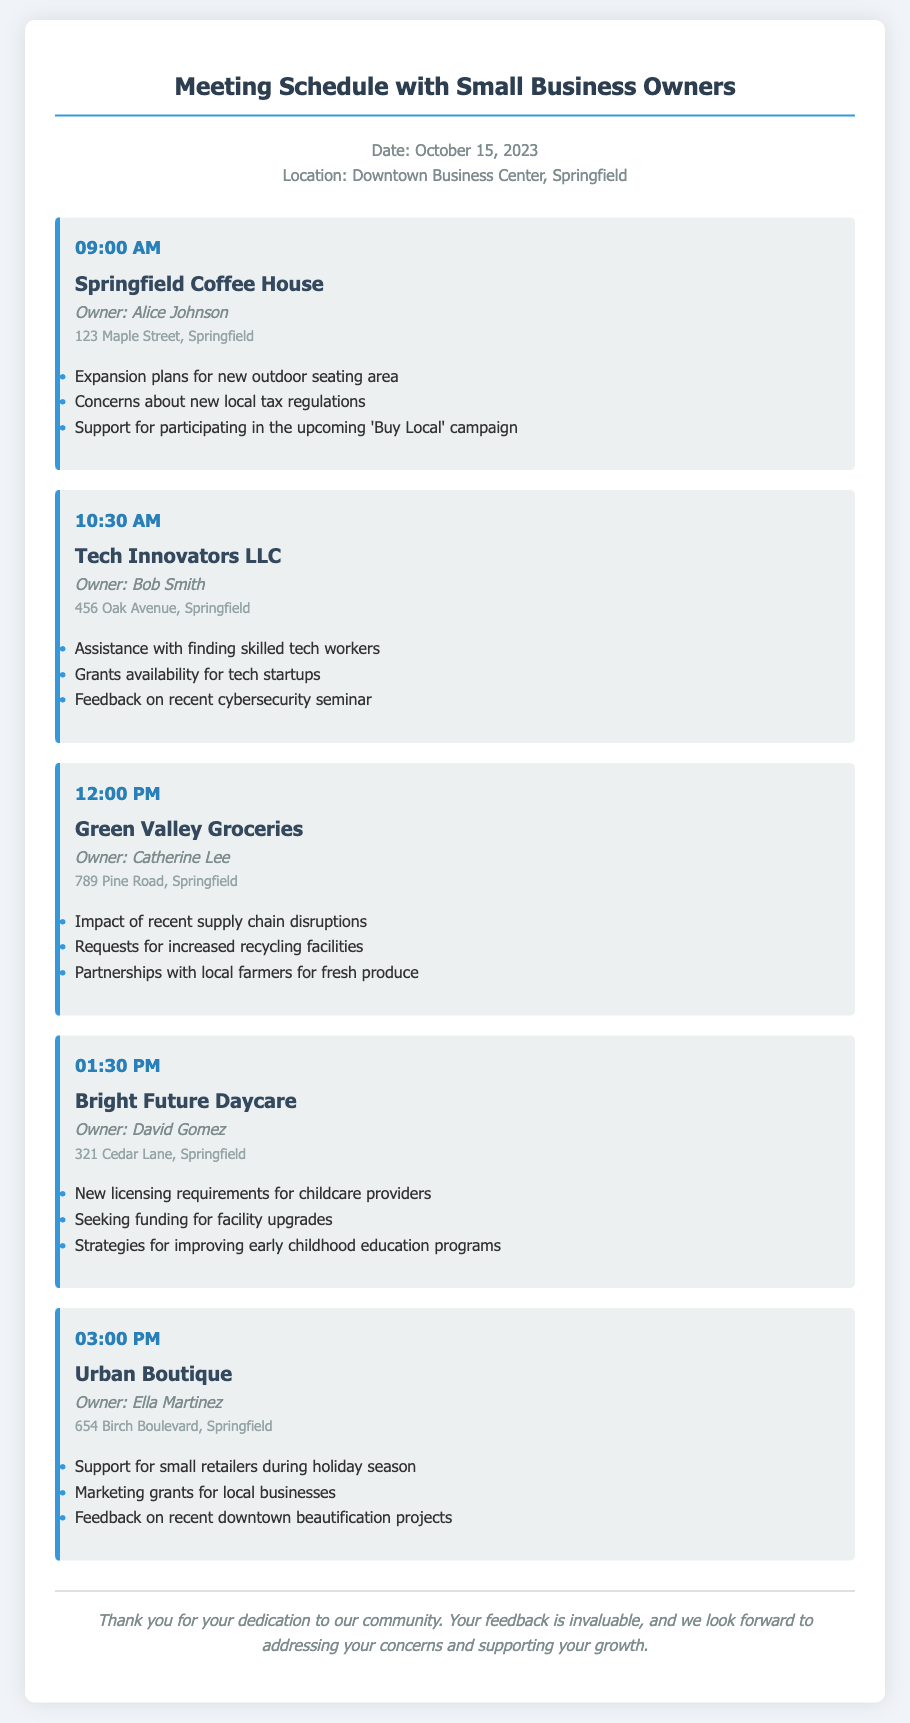what is the date of the meeting schedule? The date of the meeting schedule is clearly mentioned in the document as October 15, 2023.
Answer: October 15, 2023 who is the owner of the Springfield Coffee House? The document lists the owner of Springfield Coffee House as Alice Johnson.
Answer: Alice Johnson what time is the meeting with Tech Innovators LLC? The schedule indicates that the meeting with Tech Innovators LLC is at 10:30 AM.
Answer: 10:30 AM what is one concern raised by Green Valley Groceries? The document outlines several requests from Green Valley Groceries, one of which is for increased recycling facilities.
Answer: increased recycling facilities how many business owners are meeting today? The document lists five different business owners in total.
Answer: five what type of assistance is Tech Innovators LLC seeking? The document states that Tech Innovators LLC is looking for assistance with finding skilled tech workers.
Answer: finding skilled tech workers what is a topic of discussion at the meeting with Bright Future Daycare? The meeting document includes discussions about new licensing requirements for childcare providers as a topic.
Answer: new licensing requirements for childcare providers what does Urban Boutique request support for? The document notes that Urban Boutique requests support for small retailers during the holiday season.
Answer: small retailers during holiday season what is the location of the meetings? The meetings are scheduled to take place at the Downtown Business Center, Springfield.
Answer: Downtown Business Center, Springfield 